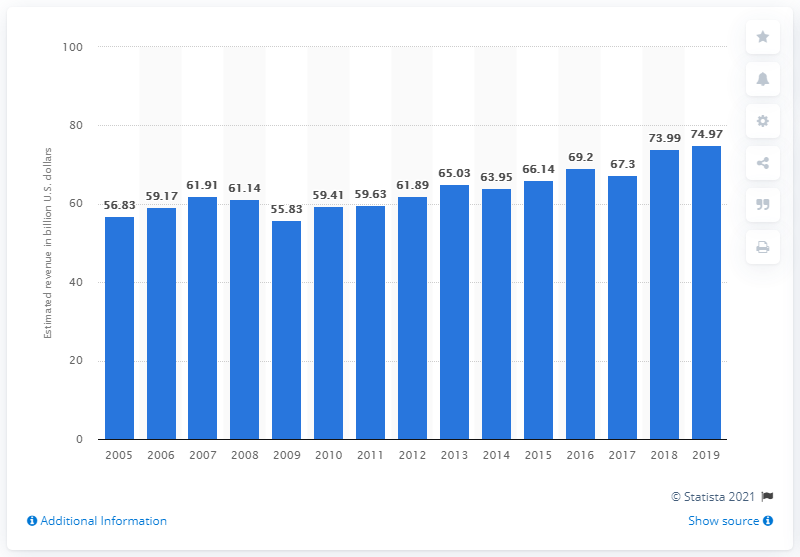Indicate a few pertinent items in this graphic. In the year 2019, the U.S. motion picture and video production and distribution industry generated the highest annual aggregate revenue to date. 